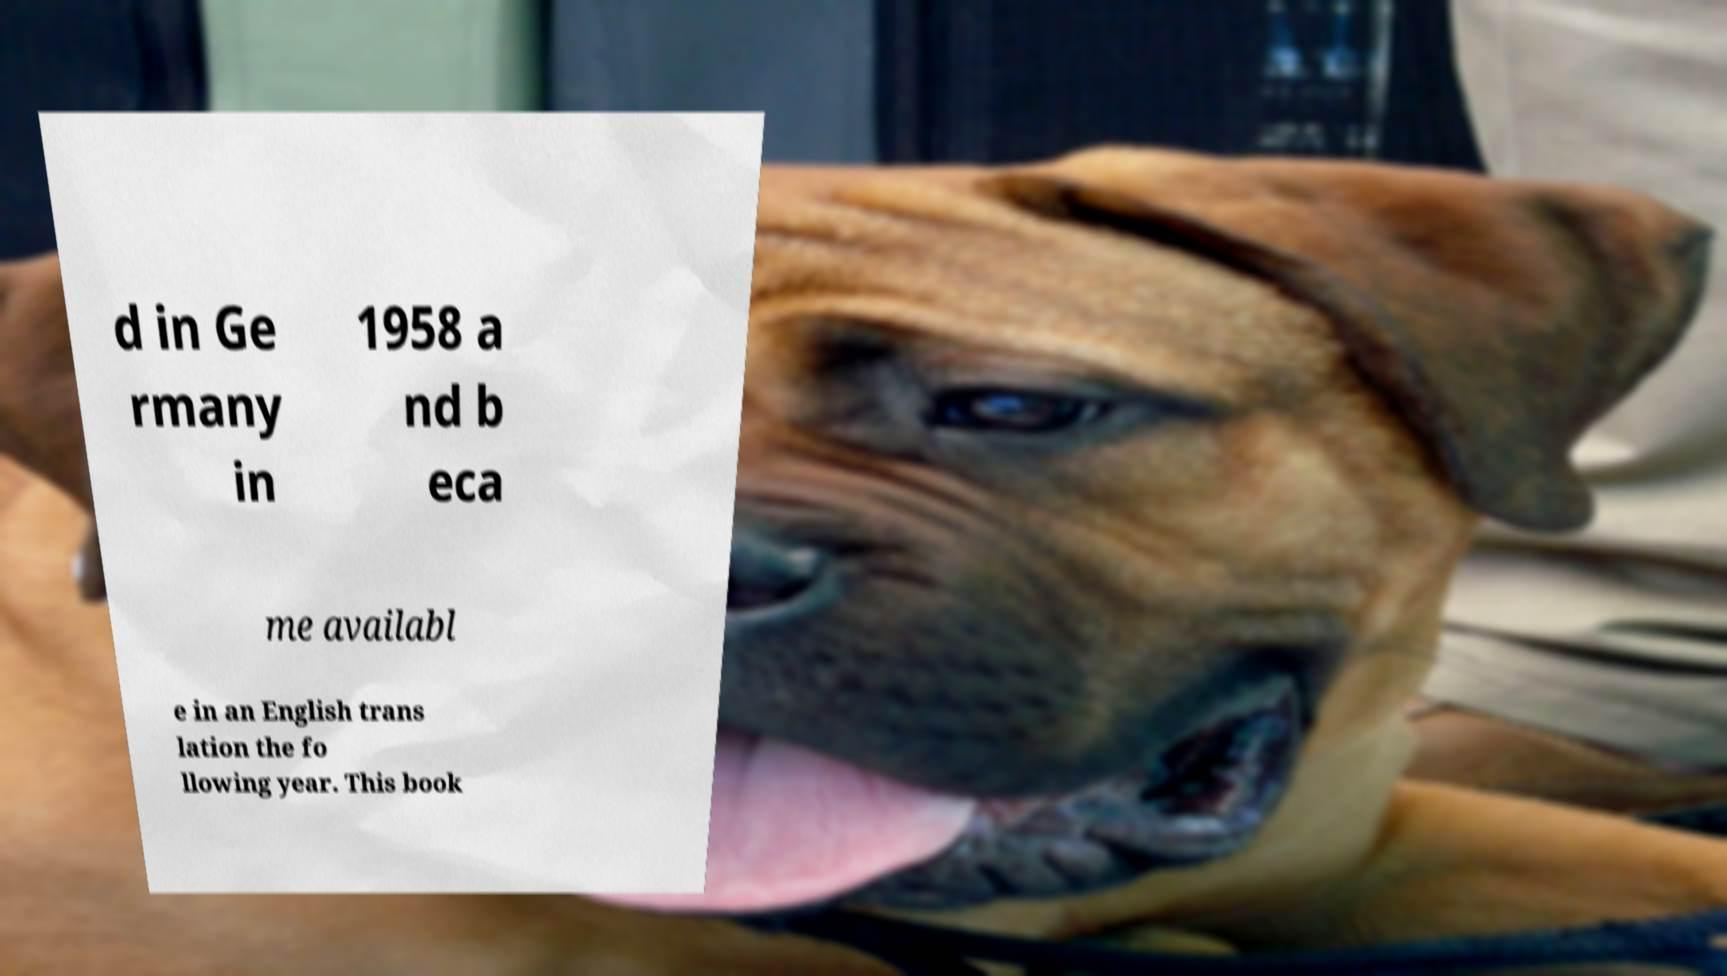Could you extract and type out the text from this image? d in Ge rmany in 1958 a nd b eca me availabl e in an English trans lation the fo llowing year. This book 